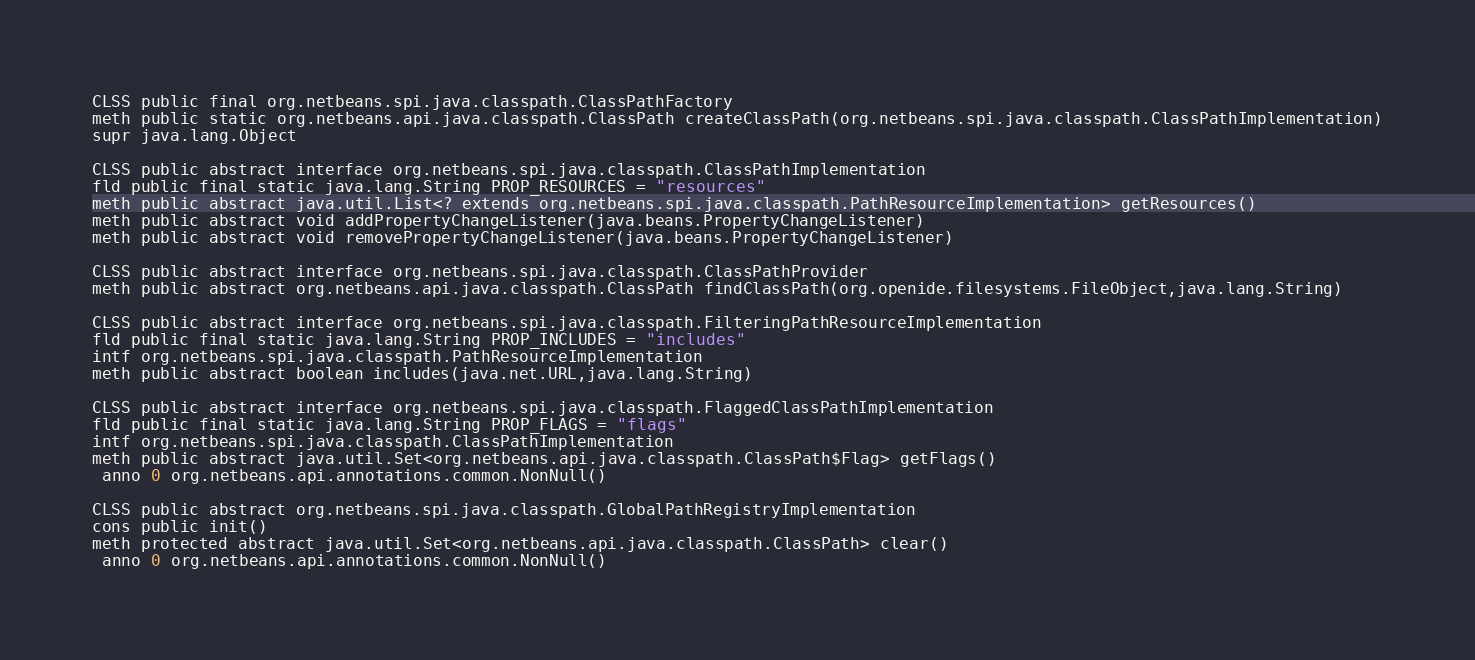<code> <loc_0><loc_0><loc_500><loc_500><_SML_>
CLSS public final org.netbeans.spi.java.classpath.ClassPathFactory
meth public static org.netbeans.api.java.classpath.ClassPath createClassPath(org.netbeans.spi.java.classpath.ClassPathImplementation)
supr java.lang.Object

CLSS public abstract interface org.netbeans.spi.java.classpath.ClassPathImplementation
fld public final static java.lang.String PROP_RESOURCES = "resources"
meth public abstract java.util.List<? extends org.netbeans.spi.java.classpath.PathResourceImplementation> getResources()
meth public abstract void addPropertyChangeListener(java.beans.PropertyChangeListener)
meth public abstract void removePropertyChangeListener(java.beans.PropertyChangeListener)

CLSS public abstract interface org.netbeans.spi.java.classpath.ClassPathProvider
meth public abstract org.netbeans.api.java.classpath.ClassPath findClassPath(org.openide.filesystems.FileObject,java.lang.String)

CLSS public abstract interface org.netbeans.spi.java.classpath.FilteringPathResourceImplementation
fld public final static java.lang.String PROP_INCLUDES = "includes"
intf org.netbeans.spi.java.classpath.PathResourceImplementation
meth public abstract boolean includes(java.net.URL,java.lang.String)

CLSS public abstract interface org.netbeans.spi.java.classpath.FlaggedClassPathImplementation
fld public final static java.lang.String PROP_FLAGS = "flags"
intf org.netbeans.spi.java.classpath.ClassPathImplementation
meth public abstract java.util.Set<org.netbeans.api.java.classpath.ClassPath$Flag> getFlags()
 anno 0 org.netbeans.api.annotations.common.NonNull()

CLSS public abstract org.netbeans.spi.java.classpath.GlobalPathRegistryImplementation
cons public init()
meth protected abstract java.util.Set<org.netbeans.api.java.classpath.ClassPath> clear()
 anno 0 org.netbeans.api.annotations.common.NonNull()</code> 